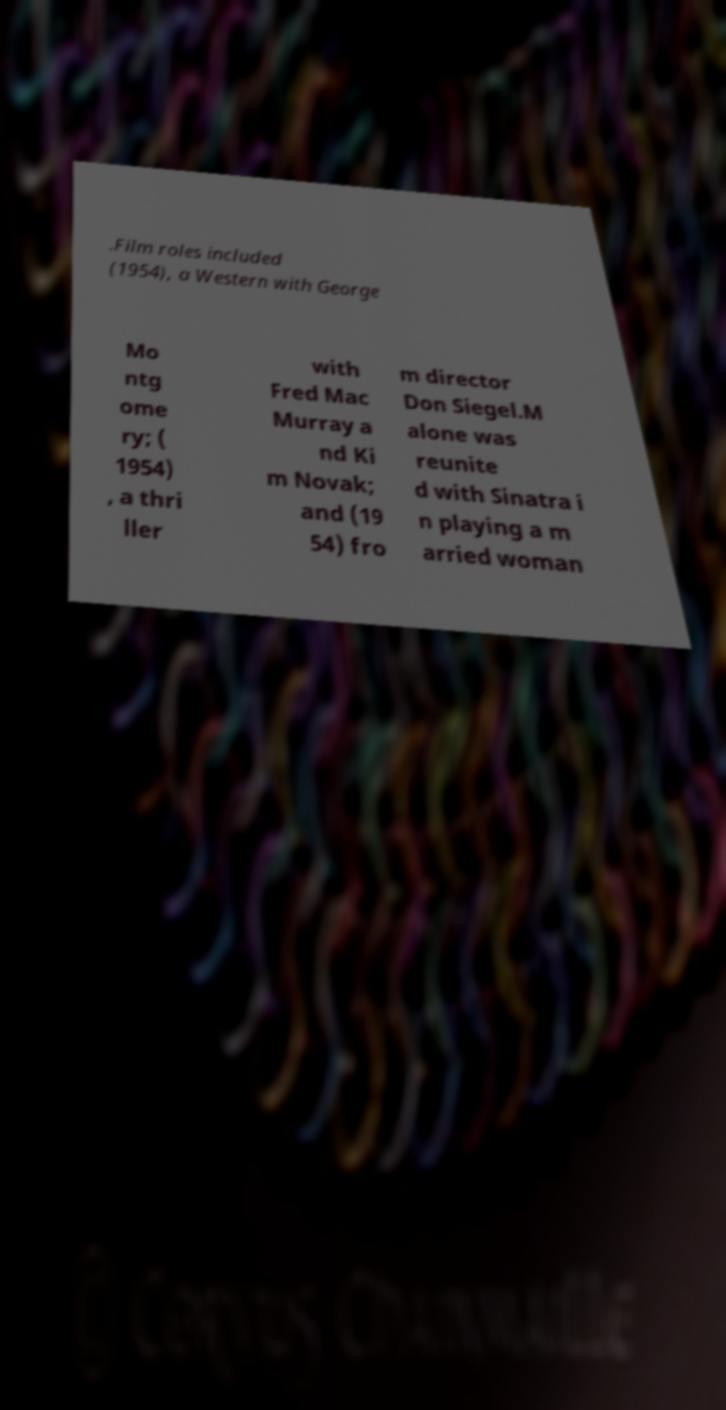Could you assist in decoding the text presented in this image and type it out clearly? .Film roles included (1954), a Western with George Mo ntg ome ry; ( 1954) , a thri ller with Fred Mac Murray a nd Ki m Novak; and (19 54) fro m director Don Siegel.M alone was reunite d with Sinatra i n playing a m arried woman 